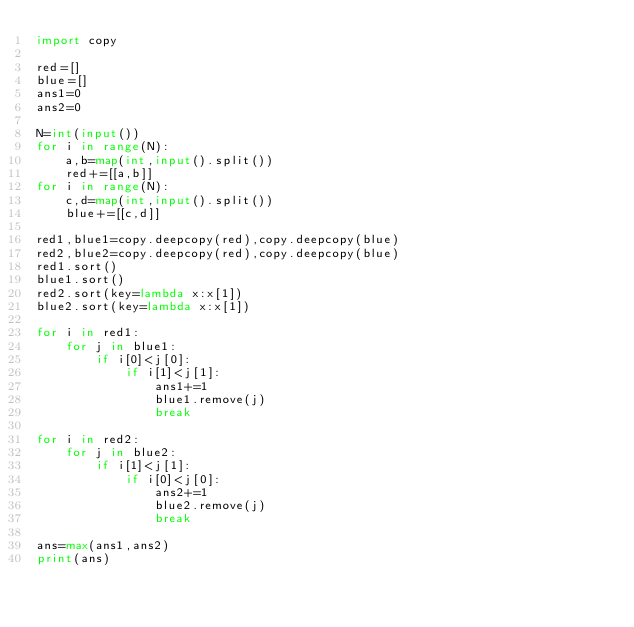Convert code to text. <code><loc_0><loc_0><loc_500><loc_500><_Python_>import copy

red=[]
blue=[]
ans1=0
ans2=0

N=int(input())
for i in range(N):
    a,b=map(int,input().split())
    red+=[[a,b]]
for i in range(N):
    c,d=map(int,input().split())
    blue+=[[c,d]]

red1,blue1=copy.deepcopy(red),copy.deepcopy(blue)
red2,blue2=copy.deepcopy(red),copy.deepcopy(blue)
red1.sort()
blue1.sort()
red2.sort(key=lambda x:x[1])
blue2.sort(key=lambda x:x[1])

for i in red1:
    for j in blue1:
        if i[0]<j[0]:
            if i[1]<j[1]:
                ans1+=1
                blue1.remove(j)
                break

for i in red2:
    for j in blue2:
        if i[1]<j[1]:
            if i[0]<j[0]:
                ans2+=1
                blue2.remove(j)
                break

ans=max(ans1,ans2)
print(ans)</code> 